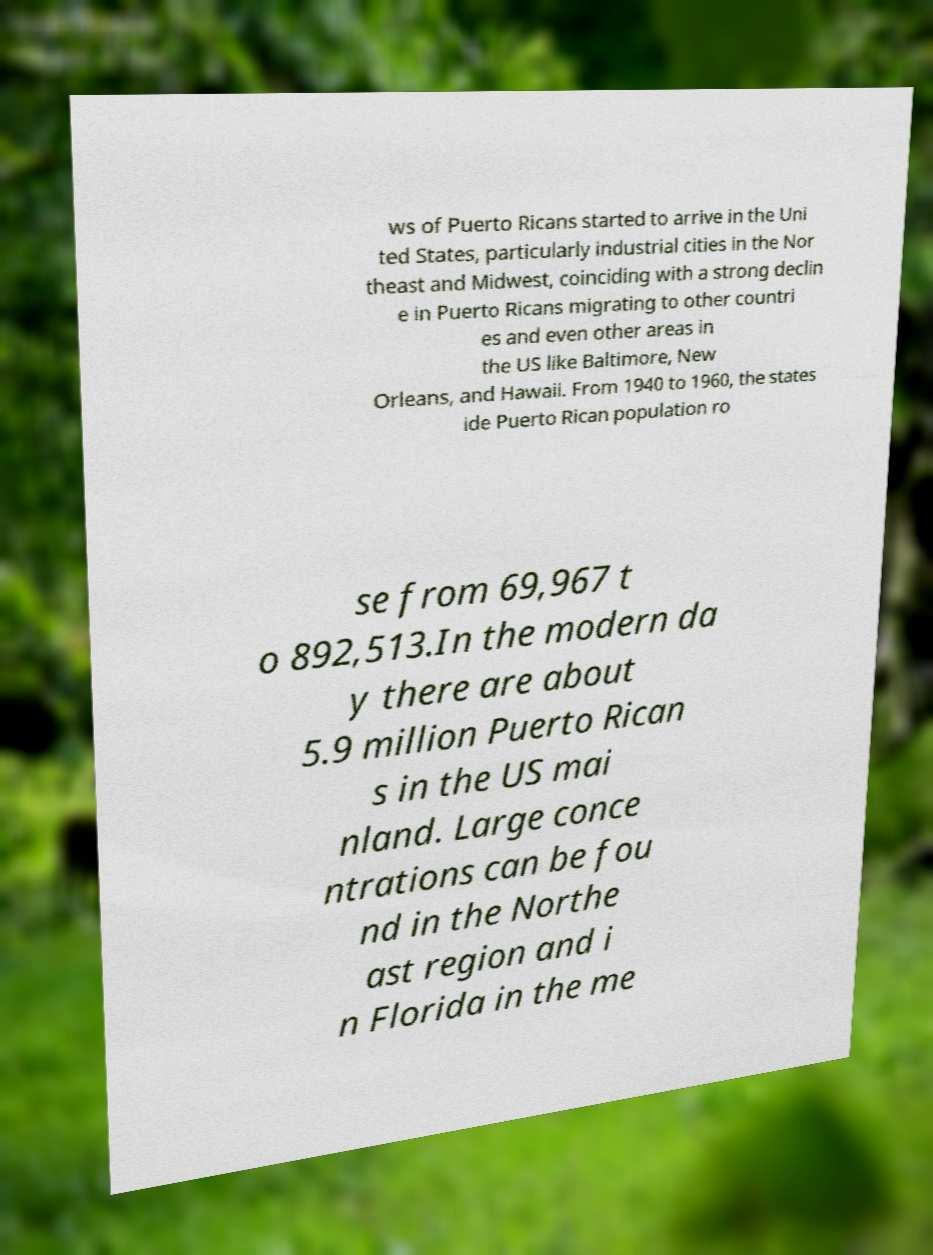I need the written content from this picture converted into text. Can you do that? ws of Puerto Ricans started to arrive in the Uni ted States, particularly industrial cities in the Nor theast and Midwest, coinciding with a strong declin e in Puerto Ricans migrating to other countri es and even other areas in the US like Baltimore, New Orleans, and Hawaii. From 1940 to 1960, the states ide Puerto Rican population ro se from 69,967 t o 892,513.In the modern da y there are about 5.9 million Puerto Rican s in the US mai nland. Large conce ntrations can be fou nd in the Northe ast region and i n Florida in the me 